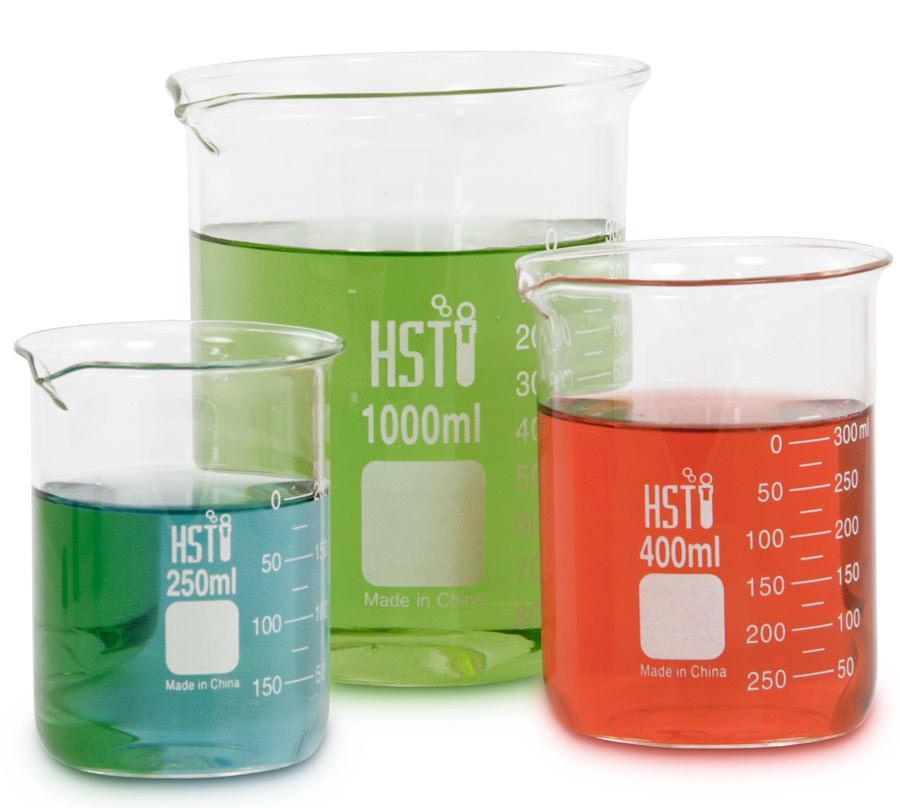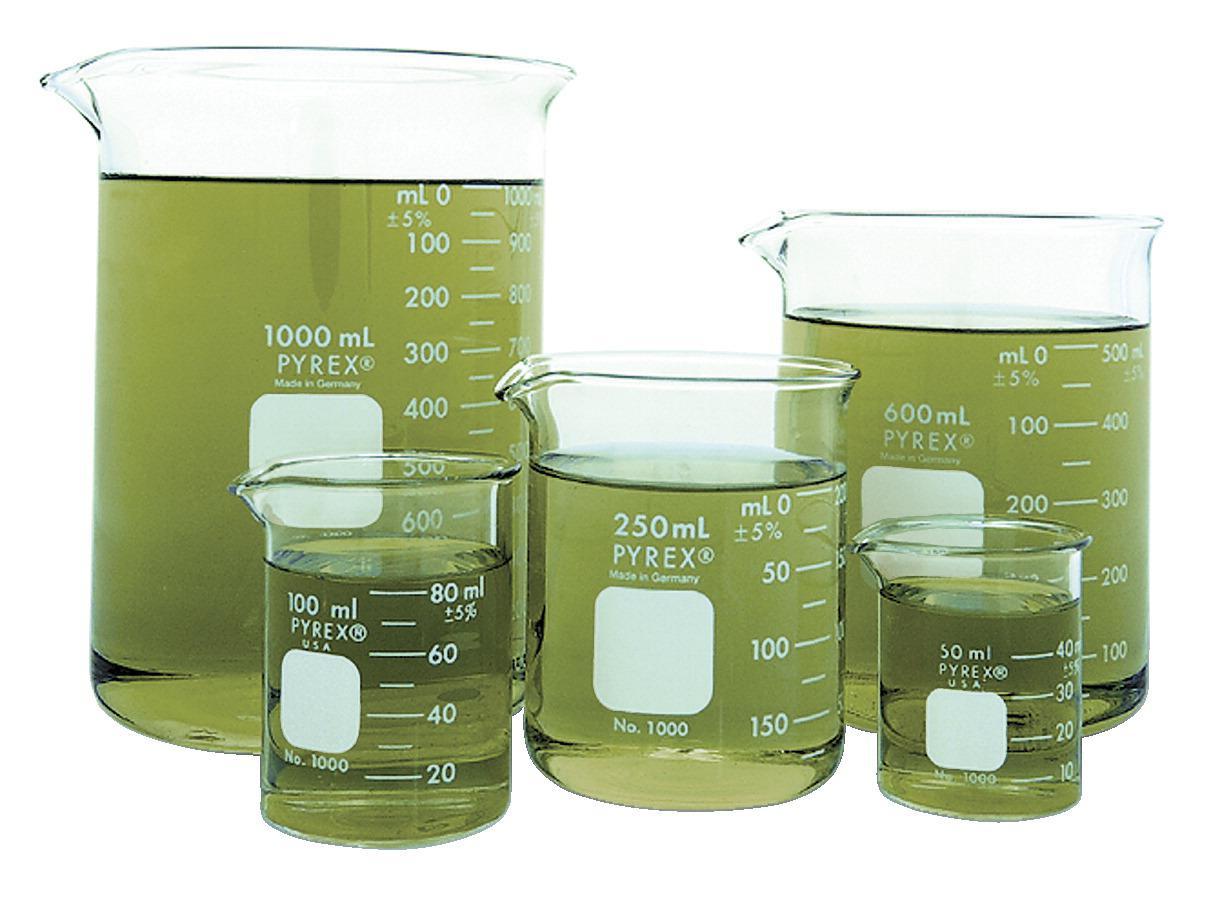The first image is the image on the left, the second image is the image on the right. Considering the images on both sides, is "There are three beakers on the left, filled with red, blue, and green liquid." valid? Answer yes or no. Yes. The first image is the image on the left, the second image is the image on the right. Considering the images on both sides, is "There are two beakers with red liquid in them." valid? Answer yes or no. No. 